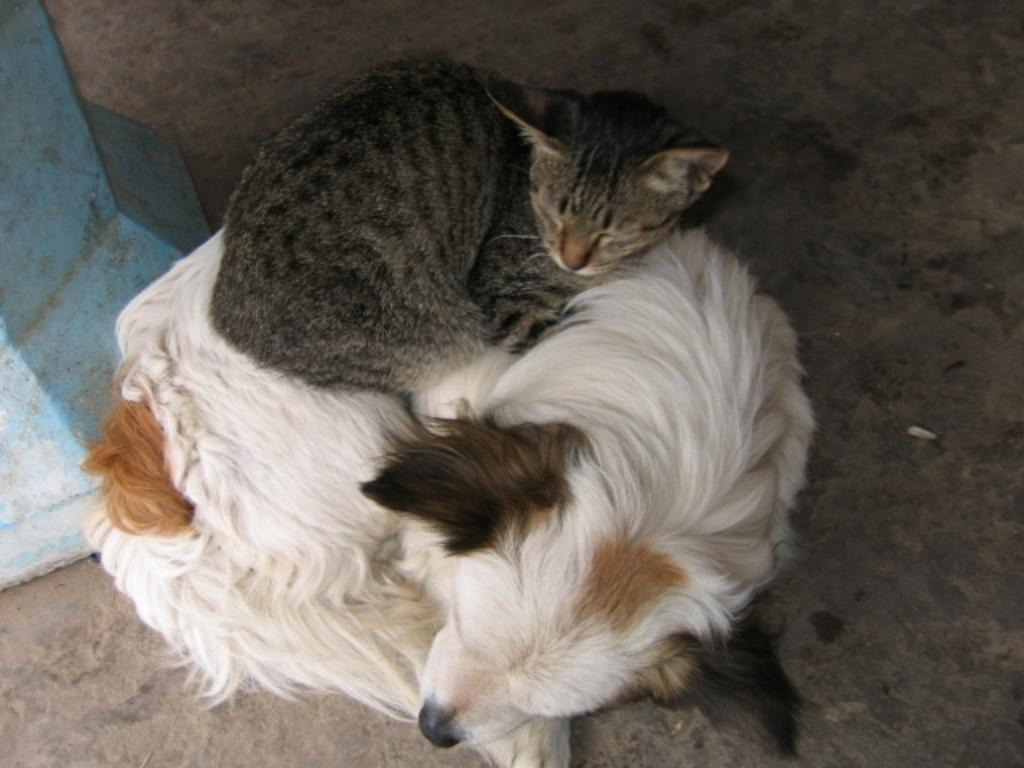What type of animal can be seen in the image? There is a dog in the image. What is the dog doing in the image? The dog is laying on a surface. Are there any other animals present in the image? Yes, there is a cat in the image. What is the cat doing in the image? The cat is laying on the dog. What type of sail can be seen on the edge of the image? There is no sail present in the image, and the edge of the image does not contain any relevant information. 